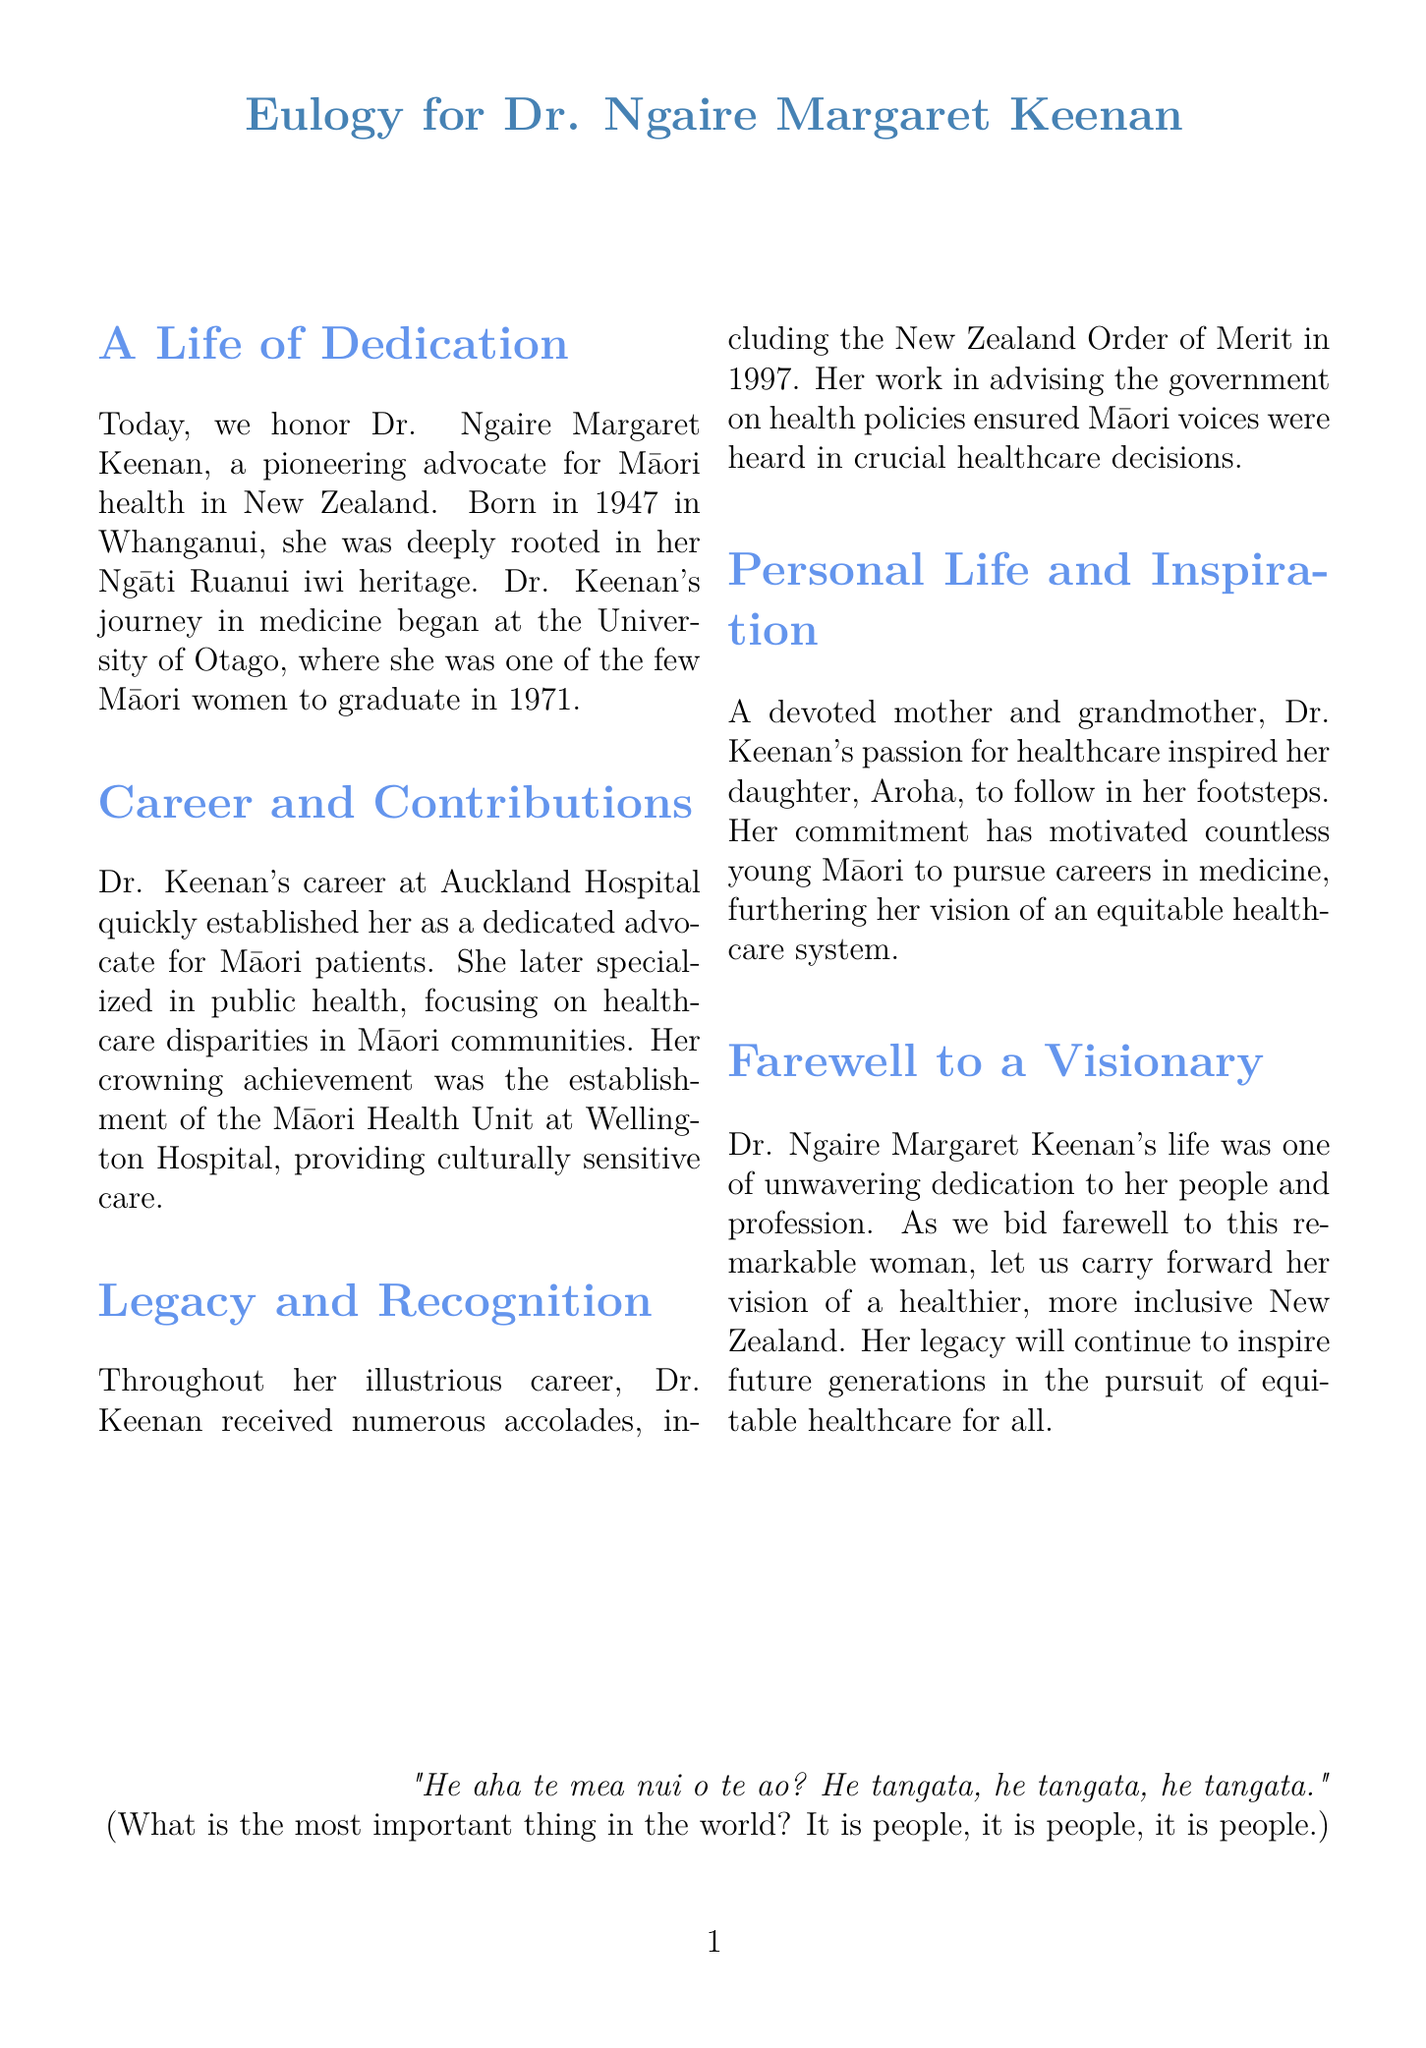what is the birth year of Dr. Ngaire Margaret Keenan? The birth year is explicitly mentioned in the document.
Answer: 1947 where did Dr. Keenan graduate from? The document states her educational institution clearly.
Answer: University of Otago which hospital did Dr. Keenan work at early in her career? This information is found in the career section of the document.
Answer: Auckland Hospital what award did Dr. Keenan receive in 1997? The document highlights this recognition.
Answer: New Zealand Order of Merit what unit did Dr. Keenan establish at Wellington Hospital? The text specifies the name of the unit she founded.
Answer: Māori Health Unit how many children did Dr. Keenan have? The document alludes to her family but does not directly state the number of children.
Answer: One (Aroha) what was Dr. Keenan's main focus in public health? Her specialization is detailed within the contributions section.
Answer: Healthcare disparities in Māori communities what is the overarching theme of Dr. Keenan's legacy? The document provides insight into her lasting impact.
Answer: Equitable healthcare for all 